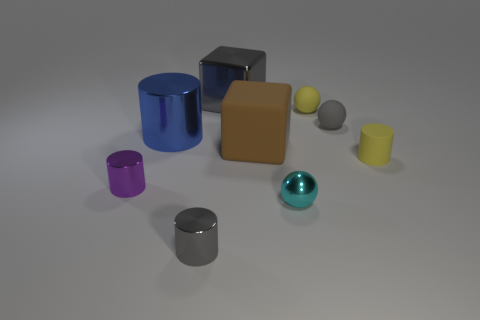Which two objects seem closest in size? The purple cylinder and the yellow cylinder appear to be the closest in size when comparing their dimensions visually. 